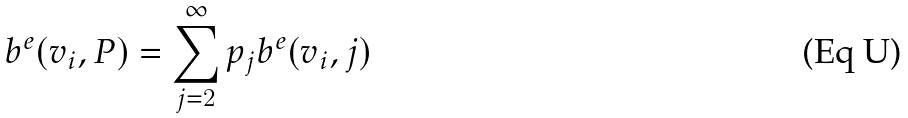<formula> <loc_0><loc_0><loc_500><loc_500>b ^ { e } ( v _ { i } , P ) = \sum _ { j = 2 } ^ { \infty } p _ { j } b ^ { e } ( v _ { i } , j )</formula> 